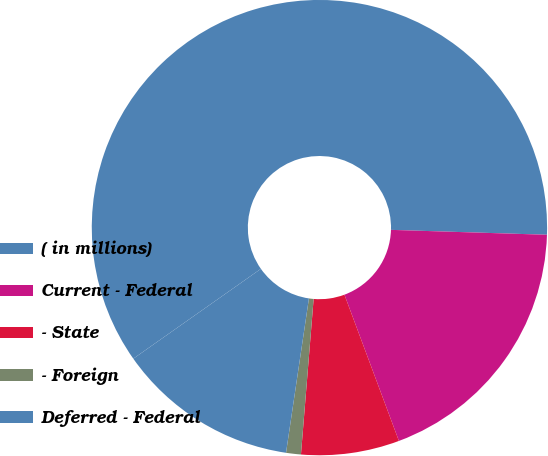<chart> <loc_0><loc_0><loc_500><loc_500><pie_chart><fcel>( in millions)<fcel>Current - Federal<fcel>- State<fcel>- Foreign<fcel>Deferred - Federal<nl><fcel>60.26%<fcel>18.82%<fcel>6.97%<fcel>1.05%<fcel>12.89%<nl></chart> 